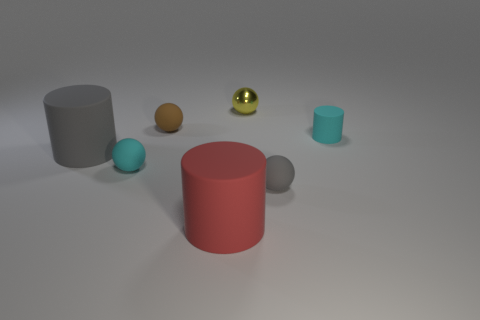Add 1 cylinders. How many objects exist? 8 Subtract all balls. How many objects are left? 3 Add 5 tiny brown balls. How many tiny brown balls are left? 6 Add 3 brown matte balls. How many brown matte balls exist? 4 Subtract 1 cyan cylinders. How many objects are left? 6 Subtract all tiny yellow things. Subtract all large green cylinders. How many objects are left? 6 